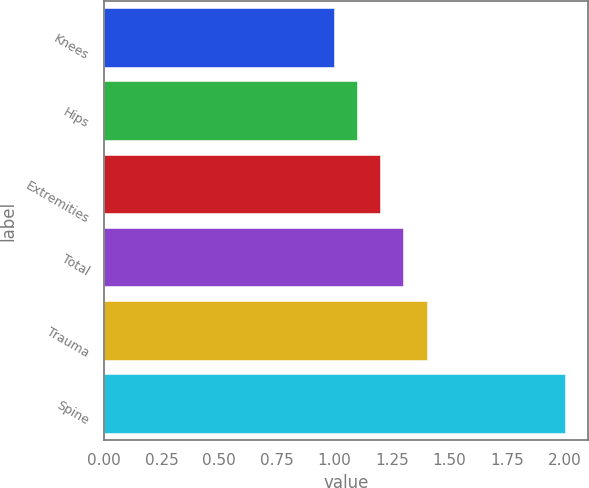<chart> <loc_0><loc_0><loc_500><loc_500><bar_chart><fcel>Knees<fcel>Hips<fcel>Extremities<fcel>Total<fcel>Trauma<fcel>Spine<nl><fcel>1<fcel>1.1<fcel>1.2<fcel>1.3<fcel>1.4<fcel>2<nl></chart> 